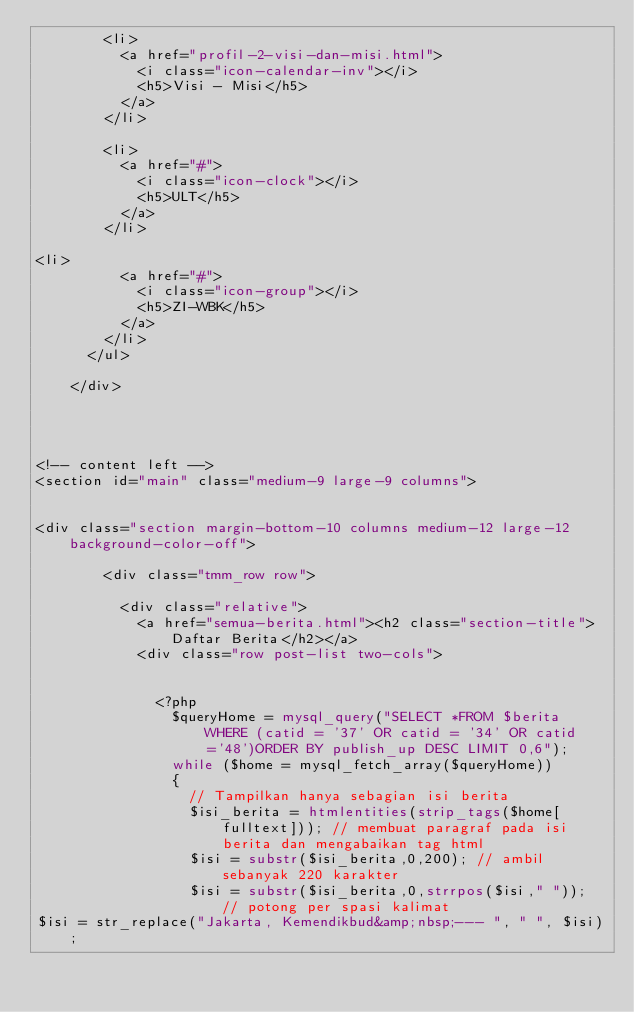Convert code to text. <code><loc_0><loc_0><loc_500><loc_500><_PHP_>				<li>
					<a href="profil-2-visi-dan-misi.html">
						<i class="icon-calendar-inv"></i>
						<h5>Visi - Misi</h5>
					</a>
				</li>
				
				<li>
					<a href="#">
						<i class="icon-clock"></i>
						<h5>ULT</h5>
					</a>
				</li>
				
<li>
					<a href="#">
						<i class="icon-group"></i>
						<h5>ZI-WBK</h5>
					</a>
				</li>
			</ul>

		</div>




<!-- content left -->
<section id="main" class="medium-9 large-9 columns">


<div class="section margin-bottom-10 columns medium-12 large-12 background-color-off">

				<div class="tmm_row row">

					<div class="relative">
						<a href="semua-berita.html"><h2 class="section-title">Daftar Berita</h2></a>
						<div class="row post-list two-cols">


							<?php
								$queryHome = mysql_query("SELECT *FROM $berita WHERE (catid = '37' OR catid = '34' OR catid='48')ORDER BY publish_up DESC LIMIT 0,6");
								while ($home = mysql_fetch_array($queryHome))
								{
									// Tampilkan hanya sebagian isi berita
									$isi_berita = htmlentities(strip_tags($home[fulltext])); // membuat paragraf pada isi berita dan mengabaikan tag html
									$isi = substr($isi_berita,0,200); // ambil sebanyak 220 karakter
									$isi = substr($isi_berita,0,strrpos($isi," ")); // potong per spasi kalimat
$isi = str_replace("Jakarta, Kemendikbud&amp;nbsp;--- ", " ", $isi);</code> 